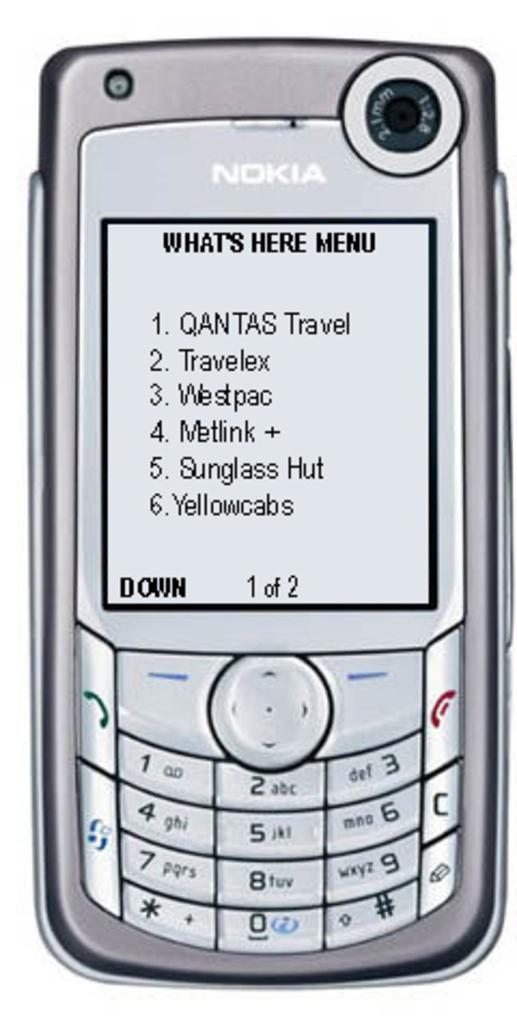What page are they on?
Your response must be concise. 1. Phone is very nice?
Offer a terse response. No. 